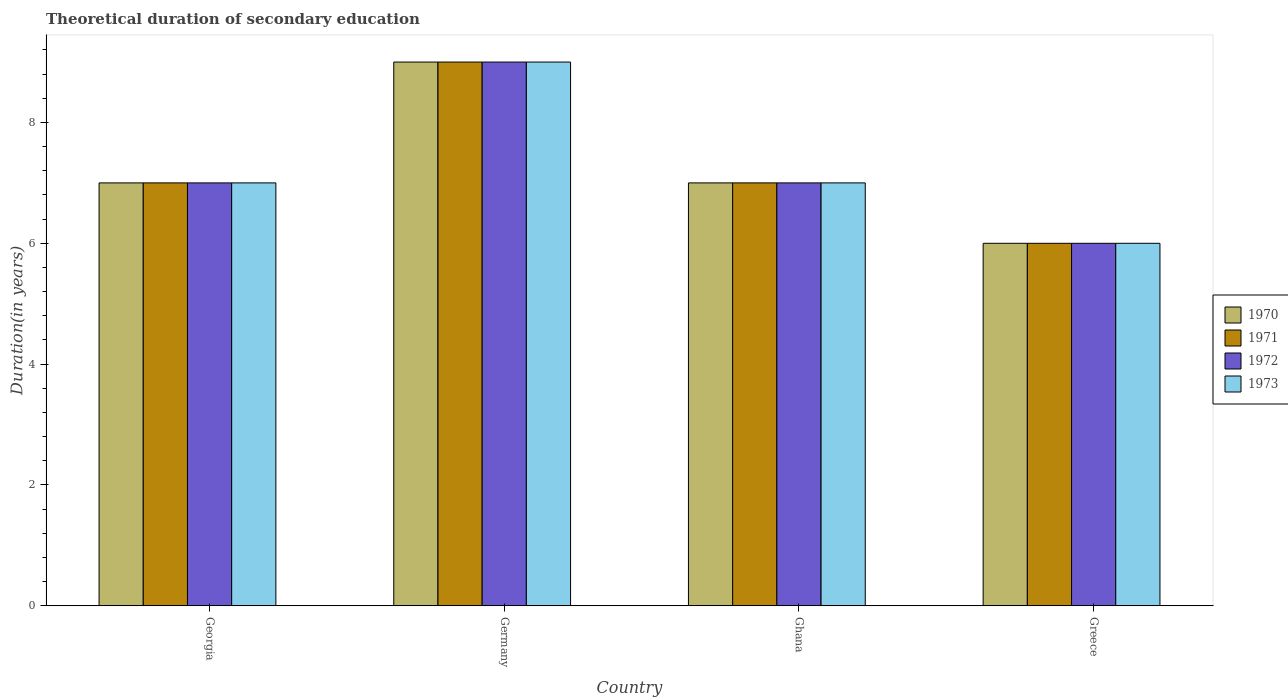How many different coloured bars are there?
Ensure brevity in your answer.  4. What is the label of the 3rd group of bars from the left?
Keep it short and to the point. Ghana. In how many cases, is the number of bars for a given country not equal to the number of legend labels?
Ensure brevity in your answer.  0. What is the total theoretical duration of secondary education in 1973 in Germany?
Offer a terse response. 9. Across all countries, what is the maximum total theoretical duration of secondary education in 1972?
Offer a terse response. 9. What is the total total theoretical duration of secondary education in 1973 in the graph?
Provide a short and direct response. 29. What is the average total theoretical duration of secondary education in 1972 per country?
Your response must be concise. 7.25. In how many countries, is the total theoretical duration of secondary education in 1973 greater than 6.8 years?
Give a very brief answer. 3. What is the ratio of the total theoretical duration of secondary education in 1972 in Germany to that in Greece?
Offer a terse response. 1.5. Is the total theoretical duration of secondary education in 1972 in Ghana less than that in Greece?
Make the answer very short. No. What is the difference between the highest and the lowest total theoretical duration of secondary education in 1972?
Provide a succinct answer. 3. In how many countries, is the total theoretical duration of secondary education in 1971 greater than the average total theoretical duration of secondary education in 1971 taken over all countries?
Keep it short and to the point. 1. Is the sum of the total theoretical duration of secondary education in 1971 in Georgia and Germany greater than the maximum total theoretical duration of secondary education in 1970 across all countries?
Your answer should be very brief. Yes. Is it the case that in every country, the sum of the total theoretical duration of secondary education in 1972 and total theoretical duration of secondary education in 1970 is greater than the sum of total theoretical duration of secondary education in 1973 and total theoretical duration of secondary education in 1971?
Offer a very short reply. No. What does the 3rd bar from the right in Greece represents?
Your answer should be very brief. 1971. Are all the bars in the graph horizontal?
Give a very brief answer. No. What is the difference between two consecutive major ticks on the Y-axis?
Make the answer very short. 2. Does the graph contain any zero values?
Offer a terse response. No. How are the legend labels stacked?
Keep it short and to the point. Vertical. What is the title of the graph?
Make the answer very short. Theoretical duration of secondary education. What is the label or title of the X-axis?
Your answer should be compact. Country. What is the label or title of the Y-axis?
Provide a short and direct response. Duration(in years). What is the Duration(in years) of 1972 in Georgia?
Your answer should be compact. 7. What is the Duration(in years) in 1971 in Germany?
Your response must be concise. 9. What is the Duration(in years) of 1973 in Germany?
Your response must be concise. 9. What is the Duration(in years) of 1972 in Ghana?
Your answer should be compact. 7. What is the Duration(in years) of 1971 in Greece?
Your answer should be compact. 6. What is the Duration(in years) in 1972 in Greece?
Keep it short and to the point. 6. What is the Duration(in years) in 1973 in Greece?
Ensure brevity in your answer.  6. Across all countries, what is the maximum Duration(in years) in 1971?
Provide a succinct answer. 9. Across all countries, what is the maximum Duration(in years) in 1972?
Your answer should be compact. 9. Across all countries, what is the minimum Duration(in years) of 1970?
Your answer should be compact. 6. Across all countries, what is the minimum Duration(in years) in 1972?
Provide a succinct answer. 6. What is the total Duration(in years) of 1970 in the graph?
Give a very brief answer. 29. What is the total Duration(in years) in 1971 in the graph?
Offer a terse response. 29. What is the total Duration(in years) in 1973 in the graph?
Your answer should be compact. 29. What is the difference between the Duration(in years) of 1971 in Georgia and that in Germany?
Your answer should be compact. -2. What is the difference between the Duration(in years) of 1972 in Georgia and that in Germany?
Make the answer very short. -2. What is the difference between the Duration(in years) of 1971 in Georgia and that in Ghana?
Your answer should be very brief. 0. What is the difference between the Duration(in years) in 1973 in Georgia and that in Ghana?
Your answer should be very brief. 0. What is the difference between the Duration(in years) of 1970 in Georgia and that in Greece?
Your answer should be compact. 1. What is the difference between the Duration(in years) of 1971 in Georgia and that in Greece?
Make the answer very short. 1. What is the difference between the Duration(in years) of 1972 in Georgia and that in Greece?
Your answer should be very brief. 1. What is the difference between the Duration(in years) of 1971 in Germany and that in Ghana?
Ensure brevity in your answer.  2. What is the difference between the Duration(in years) in 1973 in Germany and that in Ghana?
Make the answer very short. 2. What is the difference between the Duration(in years) of 1970 in Ghana and that in Greece?
Give a very brief answer. 1. What is the difference between the Duration(in years) of 1971 in Ghana and that in Greece?
Provide a succinct answer. 1. What is the difference between the Duration(in years) in 1972 in Ghana and that in Greece?
Your answer should be very brief. 1. What is the difference between the Duration(in years) of 1970 in Georgia and the Duration(in years) of 1972 in Germany?
Your answer should be compact. -2. What is the difference between the Duration(in years) of 1970 in Georgia and the Duration(in years) of 1973 in Germany?
Make the answer very short. -2. What is the difference between the Duration(in years) of 1970 in Georgia and the Duration(in years) of 1971 in Ghana?
Your response must be concise. 0. What is the difference between the Duration(in years) in 1970 in Georgia and the Duration(in years) in 1972 in Ghana?
Provide a short and direct response. 0. What is the difference between the Duration(in years) of 1971 in Georgia and the Duration(in years) of 1972 in Ghana?
Ensure brevity in your answer.  0. What is the difference between the Duration(in years) in 1971 in Georgia and the Duration(in years) in 1973 in Ghana?
Your answer should be very brief. 0. What is the difference between the Duration(in years) in 1972 in Georgia and the Duration(in years) in 1973 in Greece?
Provide a succinct answer. 1. What is the difference between the Duration(in years) in 1970 in Germany and the Duration(in years) in 1972 in Ghana?
Your response must be concise. 2. What is the difference between the Duration(in years) of 1970 in Germany and the Duration(in years) of 1973 in Ghana?
Offer a very short reply. 2. What is the difference between the Duration(in years) of 1971 in Germany and the Duration(in years) of 1973 in Ghana?
Your answer should be very brief. 2. What is the difference between the Duration(in years) of 1972 in Germany and the Duration(in years) of 1973 in Ghana?
Your answer should be compact. 2. What is the difference between the Duration(in years) of 1970 in Germany and the Duration(in years) of 1971 in Greece?
Offer a terse response. 3. What is the difference between the Duration(in years) of 1970 in Germany and the Duration(in years) of 1972 in Greece?
Ensure brevity in your answer.  3. What is the difference between the Duration(in years) of 1970 in Germany and the Duration(in years) of 1973 in Greece?
Make the answer very short. 3. What is the difference between the Duration(in years) of 1971 in Germany and the Duration(in years) of 1972 in Greece?
Provide a short and direct response. 3. What is the difference between the Duration(in years) of 1971 in Germany and the Duration(in years) of 1973 in Greece?
Your answer should be very brief. 3. What is the difference between the Duration(in years) in 1970 in Ghana and the Duration(in years) in 1972 in Greece?
Provide a short and direct response. 1. What is the difference between the Duration(in years) of 1970 in Ghana and the Duration(in years) of 1973 in Greece?
Keep it short and to the point. 1. What is the difference between the Duration(in years) of 1971 in Ghana and the Duration(in years) of 1972 in Greece?
Your response must be concise. 1. What is the difference between the Duration(in years) of 1971 in Ghana and the Duration(in years) of 1973 in Greece?
Offer a very short reply. 1. What is the difference between the Duration(in years) in 1972 in Ghana and the Duration(in years) in 1973 in Greece?
Provide a short and direct response. 1. What is the average Duration(in years) of 1970 per country?
Make the answer very short. 7.25. What is the average Duration(in years) in 1971 per country?
Keep it short and to the point. 7.25. What is the average Duration(in years) in 1972 per country?
Your response must be concise. 7.25. What is the average Duration(in years) of 1973 per country?
Your response must be concise. 7.25. What is the difference between the Duration(in years) in 1970 and Duration(in years) in 1971 in Georgia?
Offer a terse response. 0. What is the difference between the Duration(in years) in 1971 and Duration(in years) in 1972 in Germany?
Give a very brief answer. 0. What is the difference between the Duration(in years) in 1971 and Duration(in years) in 1973 in Germany?
Provide a succinct answer. 0. What is the difference between the Duration(in years) of 1970 and Duration(in years) of 1971 in Ghana?
Give a very brief answer. 0. What is the difference between the Duration(in years) in 1970 and Duration(in years) in 1972 in Ghana?
Your answer should be very brief. 0. What is the difference between the Duration(in years) in 1971 and Duration(in years) in 1972 in Ghana?
Keep it short and to the point. 0. What is the difference between the Duration(in years) in 1970 and Duration(in years) in 1971 in Greece?
Provide a succinct answer. 0. What is the difference between the Duration(in years) of 1970 and Duration(in years) of 1972 in Greece?
Make the answer very short. 0. What is the difference between the Duration(in years) of 1971 and Duration(in years) of 1972 in Greece?
Provide a short and direct response. 0. What is the ratio of the Duration(in years) in 1970 in Georgia to that in Germany?
Keep it short and to the point. 0.78. What is the ratio of the Duration(in years) of 1971 in Georgia to that in Germany?
Your answer should be compact. 0.78. What is the ratio of the Duration(in years) of 1972 in Georgia to that in Germany?
Your answer should be compact. 0.78. What is the ratio of the Duration(in years) in 1973 in Georgia to that in Ghana?
Your response must be concise. 1. What is the ratio of the Duration(in years) of 1970 in Georgia to that in Greece?
Give a very brief answer. 1.17. What is the ratio of the Duration(in years) in 1971 in Georgia to that in Greece?
Provide a short and direct response. 1.17. What is the ratio of the Duration(in years) in 1973 in Georgia to that in Greece?
Give a very brief answer. 1.17. What is the ratio of the Duration(in years) of 1973 in Germany to that in Ghana?
Make the answer very short. 1.29. What is the ratio of the Duration(in years) in 1971 in Germany to that in Greece?
Your response must be concise. 1.5. What is the ratio of the Duration(in years) in 1972 in Ghana to that in Greece?
Provide a short and direct response. 1.17. What is the difference between the highest and the second highest Duration(in years) of 1971?
Make the answer very short. 2. What is the difference between the highest and the second highest Duration(in years) in 1973?
Your response must be concise. 2. What is the difference between the highest and the lowest Duration(in years) in 1970?
Give a very brief answer. 3. What is the difference between the highest and the lowest Duration(in years) in 1973?
Provide a succinct answer. 3. 